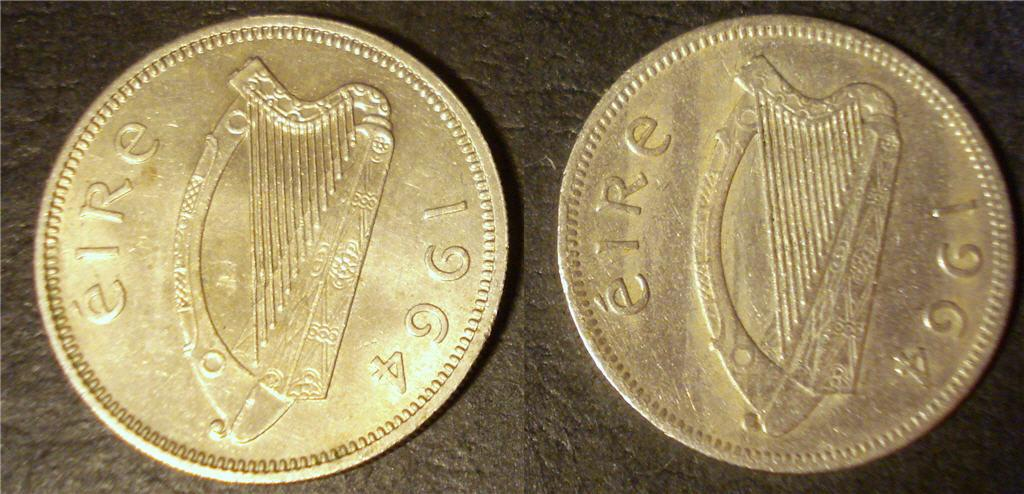<image>
Render a clear and concise summary of the photo. The old irish coins shown were made in 1964. 